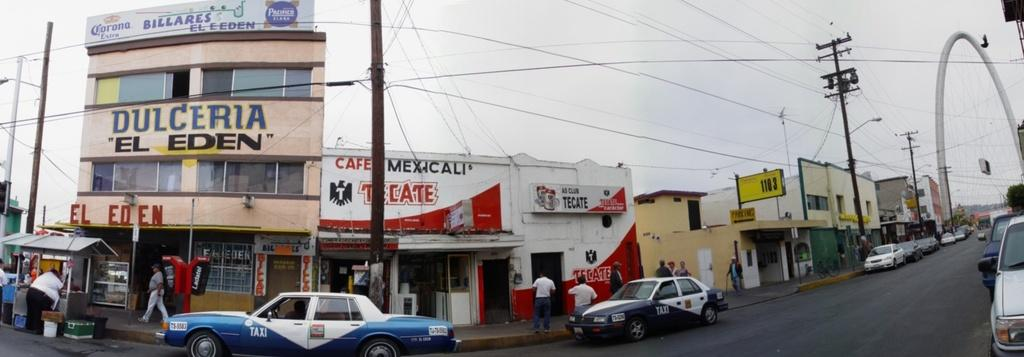<image>
Summarize the visual content of the image. a street in Mexico has stores on it like Dulceria El Eden and Cafe Mexicali. 